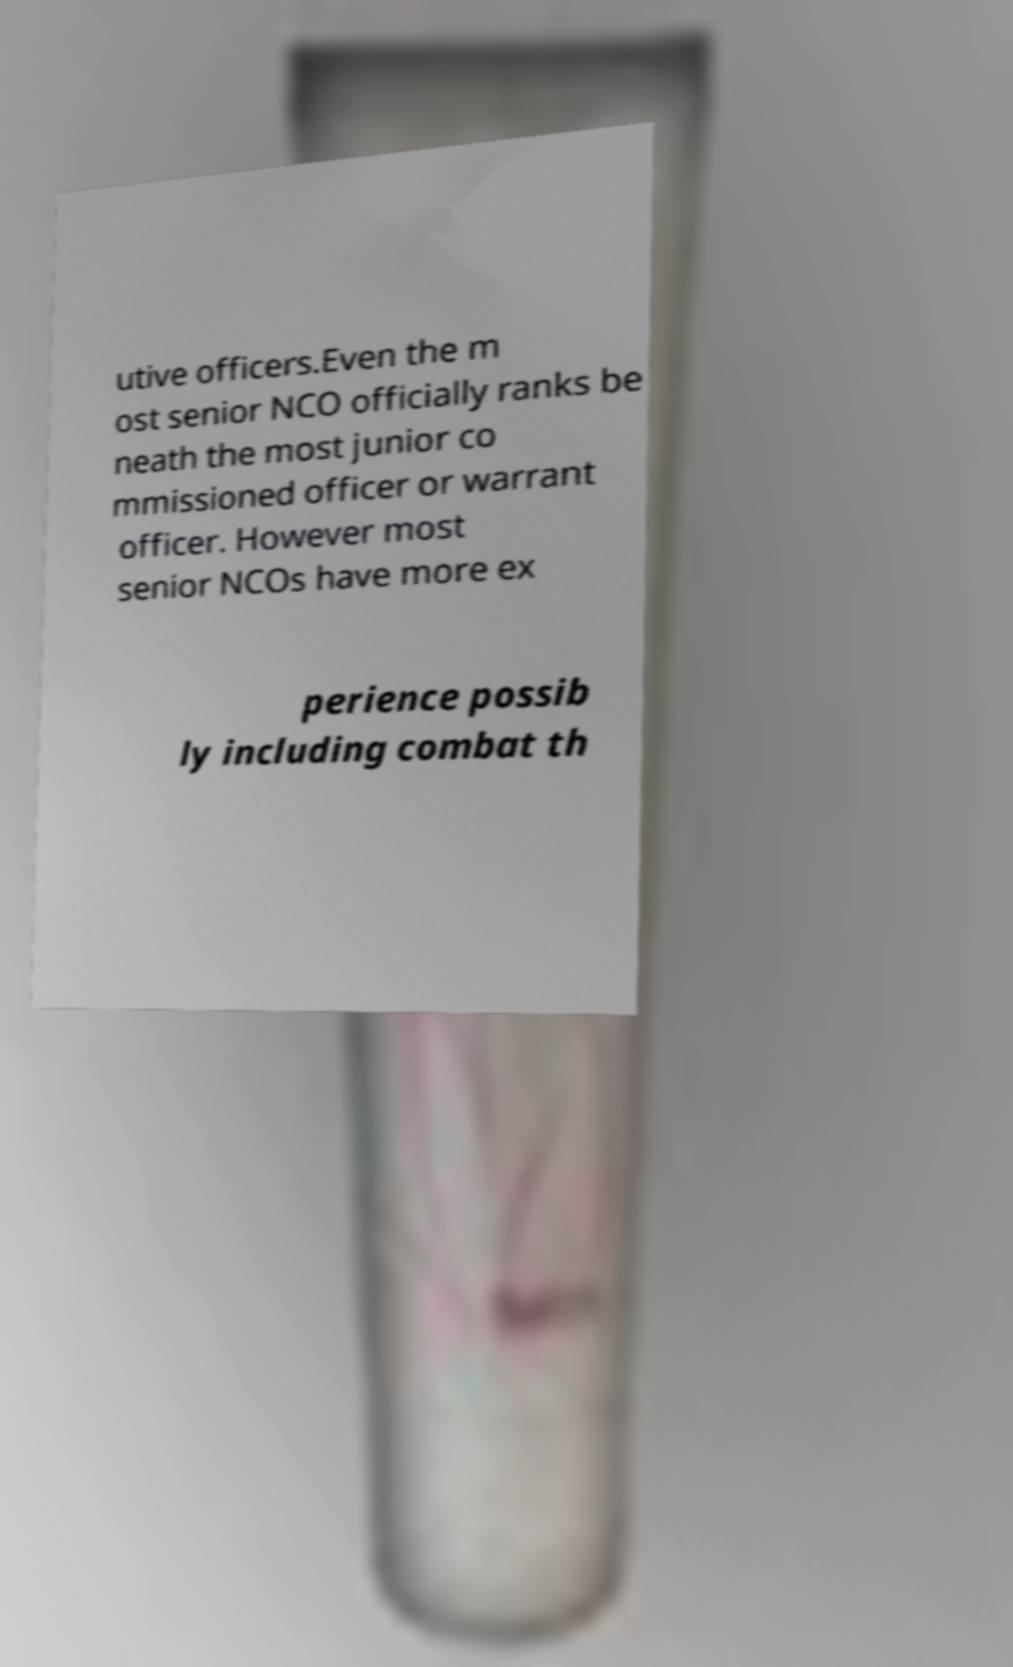What messages or text are displayed in this image? I need them in a readable, typed format. utive officers.Even the m ost senior NCO officially ranks be neath the most junior co mmissioned officer or warrant officer. However most senior NCOs have more ex perience possib ly including combat th 